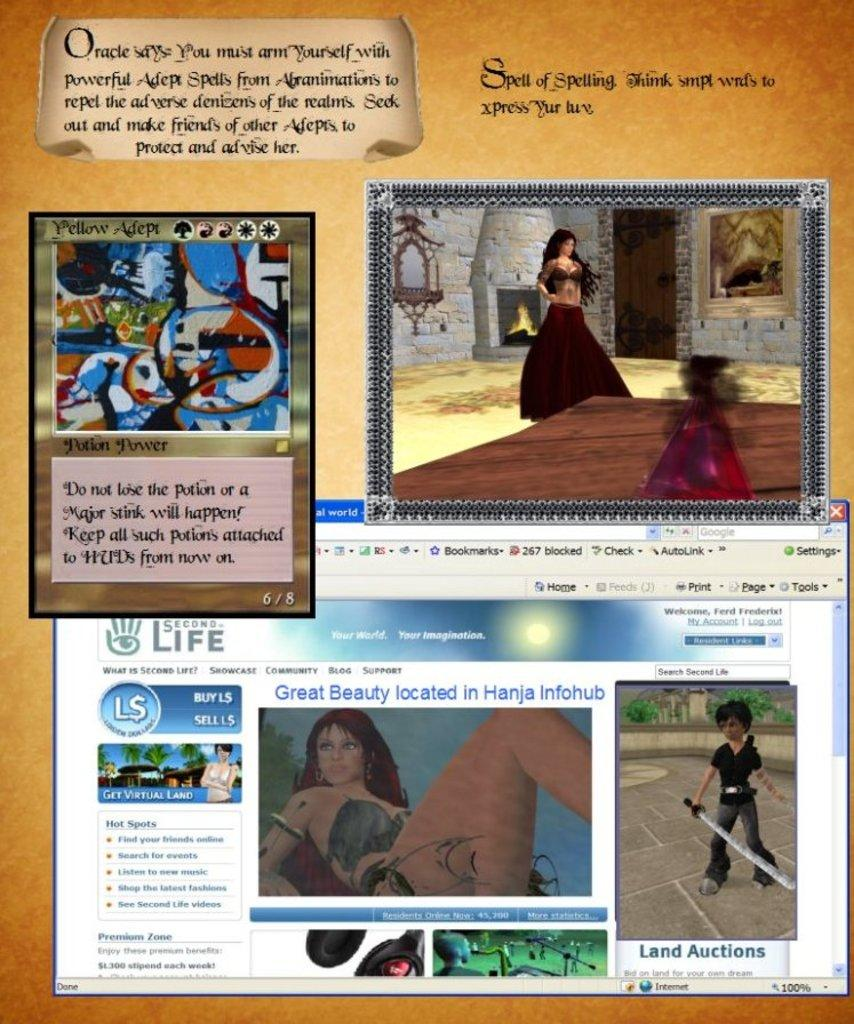What is present in the image that contains both images and text? There is a poster in the image that contains images and text. What type of hearing is the representative conducting in the image? There is no representative or hearing present in the image; it only contains a poster with images and text. 